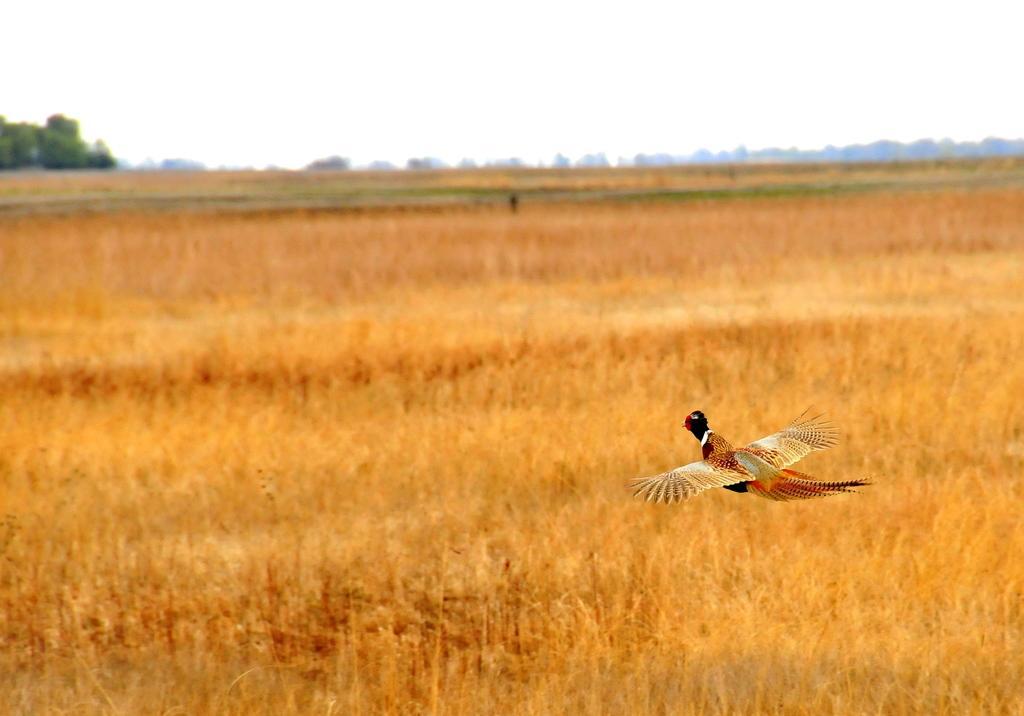Please provide a concise description of this image. We can see a bird flying in the air and we can see grass. Background we can see trees and sky. 